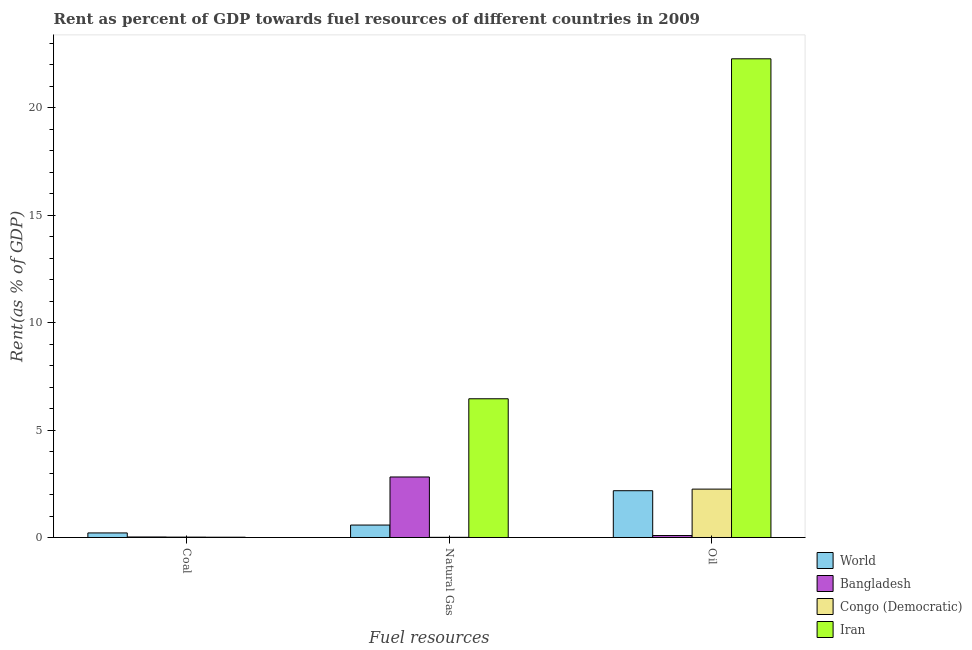How many different coloured bars are there?
Keep it short and to the point. 4. How many groups of bars are there?
Keep it short and to the point. 3. Are the number of bars per tick equal to the number of legend labels?
Your answer should be very brief. Yes. Are the number of bars on each tick of the X-axis equal?
Offer a very short reply. Yes. How many bars are there on the 2nd tick from the left?
Your answer should be compact. 4. How many bars are there on the 2nd tick from the right?
Offer a terse response. 4. What is the label of the 3rd group of bars from the left?
Ensure brevity in your answer.  Oil. What is the rent towards oil in World?
Offer a very short reply. 2.18. Across all countries, what is the maximum rent towards oil?
Provide a succinct answer. 22.28. Across all countries, what is the minimum rent towards oil?
Your answer should be very brief. 0.09. In which country was the rent towards natural gas maximum?
Offer a very short reply. Iran. In which country was the rent towards natural gas minimum?
Ensure brevity in your answer.  Congo (Democratic). What is the total rent towards natural gas in the graph?
Keep it short and to the point. 9.86. What is the difference between the rent towards coal in Bangladesh and that in Iran?
Make the answer very short. 0.01. What is the difference between the rent towards natural gas in Iran and the rent towards coal in Bangladesh?
Keep it short and to the point. 6.43. What is the average rent towards coal per country?
Make the answer very short. 0.07. What is the difference between the rent towards coal and rent towards oil in Iran?
Your answer should be compact. -22.26. What is the ratio of the rent towards oil in World to that in Congo (Democratic)?
Offer a terse response. 0.97. Is the rent towards coal in Iran less than that in Bangladesh?
Your answer should be compact. Yes. Is the difference between the rent towards natural gas in Congo (Democratic) and Iran greater than the difference between the rent towards oil in Congo (Democratic) and Iran?
Keep it short and to the point. Yes. What is the difference between the highest and the second highest rent towards oil?
Provide a succinct answer. 20.03. What is the difference between the highest and the lowest rent towards oil?
Your answer should be compact. 22.19. In how many countries, is the rent towards natural gas greater than the average rent towards natural gas taken over all countries?
Provide a short and direct response. 2. Is the sum of the rent towards oil in Congo (Democratic) and Bangladesh greater than the maximum rent towards coal across all countries?
Ensure brevity in your answer.  Yes. What does the 2nd bar from the right in Oil represents?
Your answer should be very brief. Congo (Democratic). How many countries are there in the graph?
Your answer should be compact. 4. Are the values on the major ticks of Y-axis written in scientific E-notation?
Offer a very short reply. No. Does the graph contain grids?
Keep it short and to the point. No. Where does the legend appear in the graph?
Make the answer very short. Bottom right. How are the legend labels stacked?
Make the answer very short. Vertical. What is the title of the graph?
Provide a short and direct response. Rent as percent of GDP towards fuel resources of different countries in 2009. What is the label or title of the X-axis?
Your answer should be compact. Fuel resources. What is the label or title of the Y-axis?
Your answer should be very brief. Rent(as % of GDP). What is the Rent(as % of GDP) of World in Coal?
Provide a succinct answer. 0.21. What is the Rent(as % of GDP) of Bangladesh in Coal?
Offer a very short reply. 0.02. What is the Rent(as % of GDP) of Congo (Democratic) in Coal?
Your answer should be compact. 0.02. What is the Rent(as % of GDP) of Iran in Coal?
Your answer should be very brief. 0.01. What is the Rent(as % of GDP) in World in Natural Gas?
Offer a very short reply. 0.58. What is the Rent(as % of GDP) of Bangladesh in Natural Gas?
Offer a very short reply. 2.82. What is the Rent(as % of GDP) in Congo (Democratic) in Natural Gas?
Keep it short and to the point. 0.01. What is the Rent(as % of GDP) of Iran in Natural Gas?
Make the answer very short. 6.46. What is the Rent(as % of GDP) in World in Oil?
Offer a terse response. 2.18. What is the Rent(as % of GDP) in Bangladesh in Oil?
Your response must be concise. 0.09. What is the Rent(as % of GDP) in Congo (Democratic) in Oil?
Give a very brief answer. 2.25. What is the Rent(as % of GDP) of Iran in Oil?
Provide a succinct answer. 22.28. Across all Fuel resources, what is the maximum Rent(as % of GDP) in World?
Your answer should be compact. 2.18. Across all Fuel resources, what is the maximum Rent(as % of GDP) of Bangladesh?
Your answer should be very brief. 2.82. Across all Fuel resources, what is the maximum Rent(as % of GDP) of Congo (Democratic)?
Your answer should be compact. 2.25. Across all Fuel resources, what is the maximum Rent(as % of GDP) in Iran?
Keep it short and to the point. 22.28. Across all Fuel resources, what is the minimum Rent(as % of GDP) in World?
Provide a short and direct response. 0.21. Across all Fuel resources, what is the minimum Rent(as % of GDP) in Bangladesh?
Your answer should be compact. 0.02. Across all Fuel resources, what is the minimum Rent(as % of GDP) of Congo (Democratic)?
Provide a succinct answer. 0.01. Across all Fuel resources, what is the minimum Rent(as % of GDP) of Iran?
Give a very brief answer. 0.01. What is the total Rent(as % of GDP) in World in the graph?
Provide a short and direct response. 2.97. What is the total Rent(as % of GDP) of Bangladesh in the graph?
Offer a very short reply. 2.93. What is the total Rent(as % of GDP) in Congo (Democratic) in the graph?
Provide a succinct answer. 2.28. What is the total Rent(as % of GDP) of Iran in the graph?
Ensure brevity in your answer.  28.75. What is the difference between the Rent(as % of GDP) in World in Coal and that in Natural Gas?
Your answer should be very brief. -0.37. What is the difference between the Rent(as % of GDP) in Bangladesh in Coal and that in Natural Gas?
Your answer should be compact. -2.79. What is the difference between the Rent(as % of GDP) in Congo (Democratic) in Coal and that in Natural Gas?
Keep it short and to the point. 0.01. What is the difference between the Rent(as % of GDP) of Iran in Coal and that in Natural Gas?
Your answer should be very brief. -6.44. What is the difference between the Rent(as % of GDP) of World in Coal and that in Oil?
Your answer should be compact. -1.97. What is the difference between the Rent(as % of GDP) of Bangladesh in Coal and that in Oil?
Your response must be concise. -0.07. What is the difference between the Rent(as % of GDP) of Congo (Democratic) in Coal and that in Oil?
Provide a succinct answer. -2.23. What is the difference between the Rent(as % of GDP) in Iran in Coal and that in Oil?
Provide a short and direct response. -22.26. What is the difference between the Rent(as % of GDP) of World in Natural Gas and that in Oil?
Offer a terse response. -1.6. What is the difference between the Rent(as % of GDP) in Bangladesh in Natural Gas and that in Oil?
Give a very brief answer. 2.72. What is the difference between the Rent(as % of GDP) in Congo (Democratic) in Natural Gas and that in Oil?
Ensure brevity in your answer.  -2.24. What is the difference between the Rent(as % of GDP) of Iran in Natural Gas and that in Oil?
Your answer should be compact. -15.82. What is the difference between the Rent(as % of GDP) in World in Coal and the Rent(as % of GDP) in Bangladesh in Natural Gas?
Make the answer very short. -2.6. What is the difference between the Rent(as % of GDP) of World in Coal and the Rent(as % of GDP) of Congo (Democratic) in Natural Gas?
Keep it short and to the point. 0.2. What is the difference between the Rent(as % of GDP) of World in Coal and the Rent(as % of GDP) of Iran in Natural Gas?
Provide a succinct answer. -6.24. What is the difference between the Rent(as % of GDP) in Bangladesh in Coal and the Rent(as % of GDP) in Congo (Democratic) in Natural Gas?
Make the answer very short. 0.02. What is the difference between the Rent(as % of GDP) of Bangladesh in Coal and the Rent(as % of GDP) of Iran in Natural Gas?
Give a very brief answer. -6.43. What is the difference between the Rent(as % of GDP) of Congo (Democratic) in Coal and the Rent(as % of GDP) of Iran in Natural Gas?
Your answer should be very brief. -6.44. What is the difference between the Rent(as % of GDP) of World in Coal and the Rent(as % of GDP) of Bangladesh in Oil?
Provide a short and direct response. 0.12. What is the difference between the Rent(as % of GDP) of World in Coal and the Rent(as % of GDP) of Congo (Democratic) in Oil?
Provide a succinct answer. -2.04. What is the difference between the Rent(as % of GDP) of World in Coal and the Rent(as % of GDP) of Iran in Oil?
Give a very brief answer. -22.07. What is the difference between the Rent(as % of GDP) in Bangladesh in Coal and the Rent(as % of GDP) in Congo (Democratic) in Oil?
Provide a short and direct response. -2.23. What is the difference between the Rent(as % of GDP) in Bangladesh in Coal and the Rent(as % of GDP) in Iran in Oil?
Offer a very short reply. -22.25. What is the difference between the Rent(as % of GDP) of Congo (Democratic) in Coal and the Rent(as % of GDP) of Iran in Oil?
Your answer should be compact. -22.26. What is the difference between the Rent(as % of GDP) in World in Natural Gas and the Rent(as % of GDP) in Bangladesh in Oil?
Your answer should be compact. 0.49. What is the difference between the Rent(as % of GDP) of World in Natural Gas and the Rent(as % of GDP) of Congo (Democratic) in Oil?
Provide a short and direct response. -1.67. What is the difference between the Rent(as % of GDP) of World in Natural Gas and the Rent(as % of GDP) of Iran in Oil?
Give a very brief answer. -21.7. What is the difference between the Rent(as % of GDP) of Bangladesh in Natural Gas and the Rent(as % of GDP) of Congo (Democratic) in Oil?
Make the answer very short. 0.56. What is the difference between the Rent(as % of GDP) in Bangladesh in Natural Gas and the Rent(as % of GDP) in Iran in Oil?
Your answer should be compact. -19.46. What is the difference between the Rent(as % of GDP) of Congo (Democratic) in Natural Gas and the Rent(as % of GDP) of Iran in Oil?
Your answer should be very brief. -22.27. What is the average Rent(as % of GDP) of World per Fuel resources?
Offer a terse response. 0.99. What is the average Rent(as % of GDP) in Congo (Democratic) per Fuel resources?
Provide a succinct answer. 0.76. What is the average Rent(as % of GDP) in Iran per Fuel resources?
Ensure brevity in your answer.  9.58. What is the difference between the Rent(as % of GDP) of World and Rent(as % of GDP) of Bangladesh in Coal?
Give a very brief answer. 0.19. What is the difference between the Rent(as % of GDP) of World and Rent(as % of GDP) of Congo (Democratic) in Coal?
Your answer should be very brief. 0.2. What is the difference between the Rent(as % of GDP) in World and Rent(as % of GDP) in Iran in Coal?
Offer a very short reply. 0.2. What is the difference between the Rent(as % of GDP) of Bangladesh and Rent(as % of GDP) of Congo (Democratic) in Coal?
Your response must be concise. 0.01. What is the difference between the Rent(as % of GDP) in Bangladesh and Rent(as % of GDP) in Iran in Coal?
Provide a succinct answer. 0.01. What is the difference between the Rent(as % of GDP) of Congo (Democratic) and Rent(as % of GDP) of Iran in Coal?
Provide a short and direct response. 0. What is the difference between the Rent(as % of GDP) of World and Rent(as % of GDP) of Bangladesh in Natural Gas?
Your answer should be very brief. -2.24. What is the difference between the Rent(as % of GDP) of World and Rent(as % of GDP) of Congo (Democratic) in Natural Gas?
Give a very brief answer. 0.57. What is the difference between the Rent(as % of GDP) of World and Rent(as % of GDP) of Iran in Natural Gas?
Keep it short and to the point. -5.88. What is the difference between the Rent(as % of GDP) in Bangladesh and Rent(as % of GDP) in Congo (Democratic) in Natural Gas?
Give a very brief answer. 2.81. What is the difference between the Rent(as % of GDP) in Bangladesh and Rent(as % of GDP) in Iran in Natural Gas?
Your answer should be compact. -3.64. What is the difference between the Rent(as % of GDP) of Congo (Democratic) and Rent(as % of GDP) of Iran in Natural Gas?
Offer a terse response. -6.45. What is the difference between the Rent(as % of GDP) in World and Rent(as % of GDP) in Bangladesh in Oil?
Provide a short and direct response. 2.09. What is the difference between the Rent(as % of GDP) in World and Rent(as % of GDP) in Congo (Democratic) in Oil?
Offer a terse response. -0.07. What is the difference between the Rent(as % of GDP) of World and Rent(as % of GDP) of Iran in Oil?
Provide a short and direct response. -20.1. What is the difference between the Rent(as % of GDP) of Bangladesh and Rent(as % of GDP) of Congo (Democratic) in Oil?
Offer a terse response. -2.16. What is the difference between the Rent(as % of GDP) in Bangladesh and Rent(as % of GDP) in Iran in Oil?
Offer a terse response. -22.19. What is the difference between the Rent(as % of GDP) of Congo (Democratic) and Rent(as % of GDP) of Iran in Oil?
Provide a short and direct response. -20.03. What is the ratio of the Rent(as % of GDP) of World in Coal to that in Natural Gas?
Provide a short and direct response. 0.37. What is the ratio of the Rent(as % of GDP) of Bangladesh in Coal to that in Natural Gas?
Offer a very short reply. 0.01. What is the ratio of the Rent(as % of GDP) in Congo (Democratic) in Coal to that in Natural Gas?
Your response must be concise. 2.32. What is the ratio of the Rent(as % of GDP) in Iran in Coal to that in Natural Gas?
Make the answer very short. 0. What is the ratio of the Rent(as % of GDP) in World in Coal to that in Oil?
Your answer should be very brief. 0.1. What is the ratio of the Rent(as % of GDP) of Bangladesh in Coal to that in Oil?
Provide a succinct answer. 0.26. What is the ratio of the Rent(as % of GDP) of Congo (Democratic) in Coal to that in Oil?
Your answer should be compact. 0.01. What is the ratio of the Rent(as % of GDP) in Iran in Coal to that in Oil?
Make the answer very short. 0. What is the ratio of the Rent(as % of GDP) of World in Natural Gas to that in Oil?
Your answer should be very brief. 0.27. What is the ratio of the Rent(as % of GDP) in Bangladesh in Natural Gas to that in Oil?
Your response must be concise. 30.93. What is the ratio of the Rent(as % of GDP) of Congo (Democratic) in Natural Gas to that in Oil?
Ensure brevity in your answer.  0. What is the ratio of the Rent(as % of GDP) of Iran in Natural Gas to that in Oil?
Give a very brief answer. 0.29. What is the difference between the highest and the second highest Rent(as % of GDP) of World?
Give a very brief answer. 1.6. What is the difference between the highest and the second highest Rent(as % of GDP) in Bangladesh?
Provide a short and direct response. 2.72. What is the difference between the highest and the second highest Rent(as % of GDP) in Congo (Democratic)?
Give a very brief answer. 2.23. What is the difference between the highest and the second highest Rent(as % of GDP) in Iran?
Offer a terse response. 15.82. What is the difference between the highest and the lowest Rent(as % of GDP) in World?
Ensure brevity in your answer.  1.97. What is the difference between the highest and the lowest Rent(as % of GDP) in Bangladesh?
Offer a terse response. 2.79. What is the difference between the highest and the lowest Rent(as % of GDP) of Congo (Democratic)?
Ensure brevity in your answer.  2.24. What is the difference between the highest and the lowest Rent(as % of GDP) in Iran?
Ensure brevity in your answer.  22.26. 